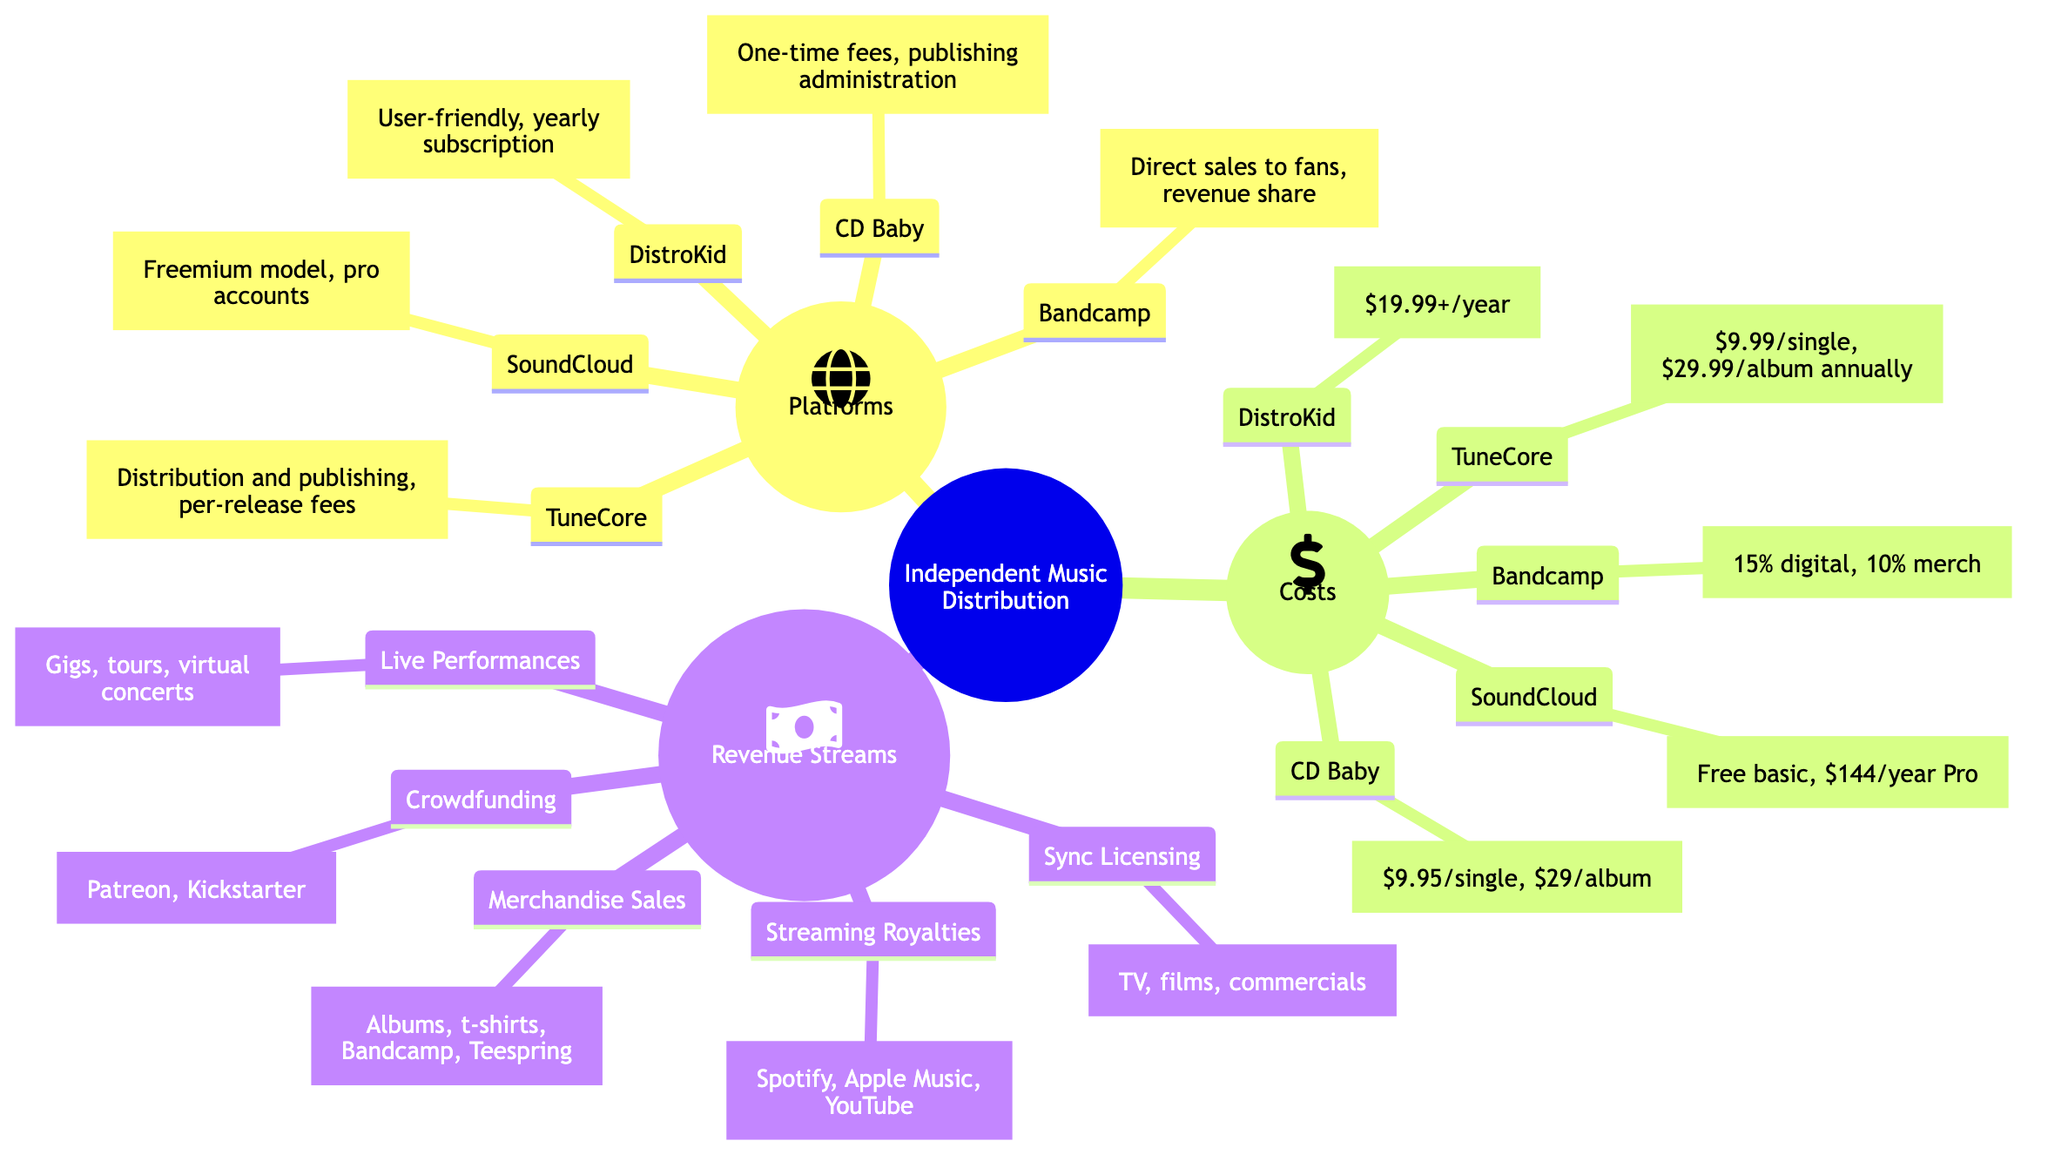What is one of the platforms listed for independent music distribution? The diagram lists several platforms under "Platforms," including DistroKid, TuneCore, CD Baby, Bandcamp, and SoundCloud. Any one of these names qualifies as an answer.
Answer: DistroKid What is the annual fee for DistroKid? The diagram states that DistroKid has an annual fee starting from $19.99 per year, which can be found directly under the "Costs" section associated with DistroKid.
Answer: $19.99 How much would it cost to release a single through TuneCore? The diagram indicates that a single release through TuneCore starts at $9.99, which is clearly noted under the "Costs" section for TuneCore.
Answer: $9.99 What percentage of revenue does Bandcamp take from digital sales? The diagram specifies that Bandcamp takes a 15% revenue share on digital sales, which is explicitly mentioned under the "Costs" section relating to Bandcamp.
Answer: 15% Which revenue stream is connected with licensing music for TV and films? In the "Revenue Streams" section, "Sync Licensing" is described as the process of earning income from licensing music for TV, films, and commercials. Thus, the answer connects to that specific element.
Answer: Sync Licensing What is one way independent artists can earn revenue from fans? Looking at the "Revenue Streams," crowdfunding is highlighted as one way to raise funds directly from fans via platforms like Patreon and Kickstarter, making it a viable method for revenue.
Answer: Crowdfunding How many platforms are listed under the Platforms section? The diagram displays five specific platforms: DistroKid, TuneCore, CD Baby, Bandcamp, and SoundCloud. By counting these elements, we arrive at the total answer.
Answer: 5 What type of account does SoundCloud offer for free? According to the diagram, SoundCloud has a free basic account mentioned in the "Costs" section. Therefore, the specific answer seeks to identify that type of account.
Answer: Basic account What are typical costs for merchandise sales on Bandcamp? The diagram states that Bandcamp has a 10% revenue share on merchandise sales. By reviewing this portion of the "Costs," we can answer the specifics regarding merchandise.
Answer: 10% 